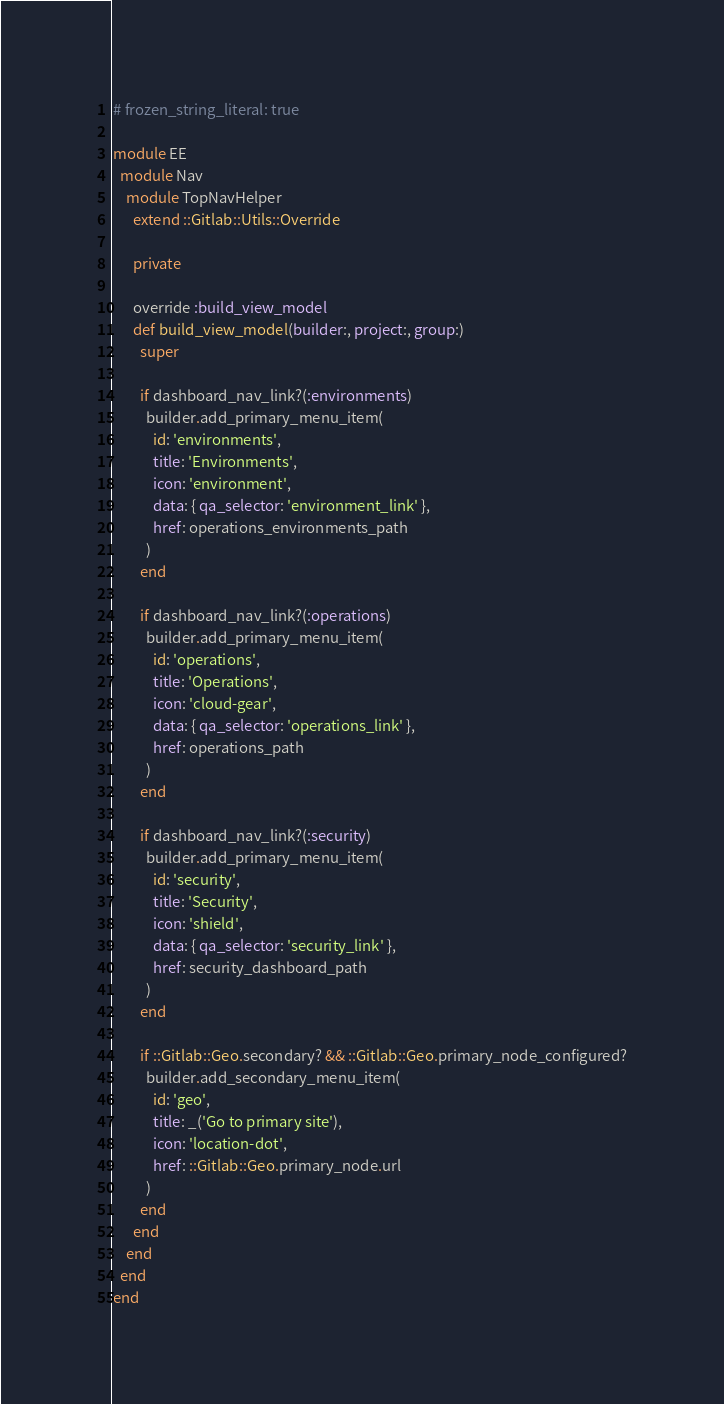<code> <loc_0><loc_0><loc_500><loc_500><_Ruby_># frozen_string_literal: true

module EE
  module Nav
    module TopNavHelper
      extend ::Gitlab::Utils::Override

      private

      override :build_view_model
      def build_view_model(builder:, project:, group:)
        super

        if dashboard_nav_link?(:environments)
          builder.add_primary_menu_item(
            id: 'environments',
            title: 'Environments',
            icon: 'environment',
            data: { qa_selector: 'environment_link' },
            href: operations_environments_path
          )
        end

        if dashboard_nav_link?(:operations)
          builder.add_primary_menu_item(
            id: 'operations',
            title: 'Operations',
            icon: 'cloud-gear',
            data: { qa_selector: 'operations_link' },
            href: operations_path
          )
        end

        if dashboard_nav_link?(:security)
          builder.add_primary_menu_item(
            id: 'security',
            title: 'Security',
            icon: 'shield',
            data: { qa_selector: 'security_link' },
            href: security_dashboard_path
          )
        end

        if ::Gitlab::Geo.secondary? && ::Gitlab::Geo.primary_node_configured?
          builder.add_secondary_menu_item(
            id: 'geo',
            title: _('Go to primary site'),
            icon: 'location-dot',
            href: ::Gitlab::Geo.primary_node.url
          )
        end
      end
    end
  end
end
</code> 